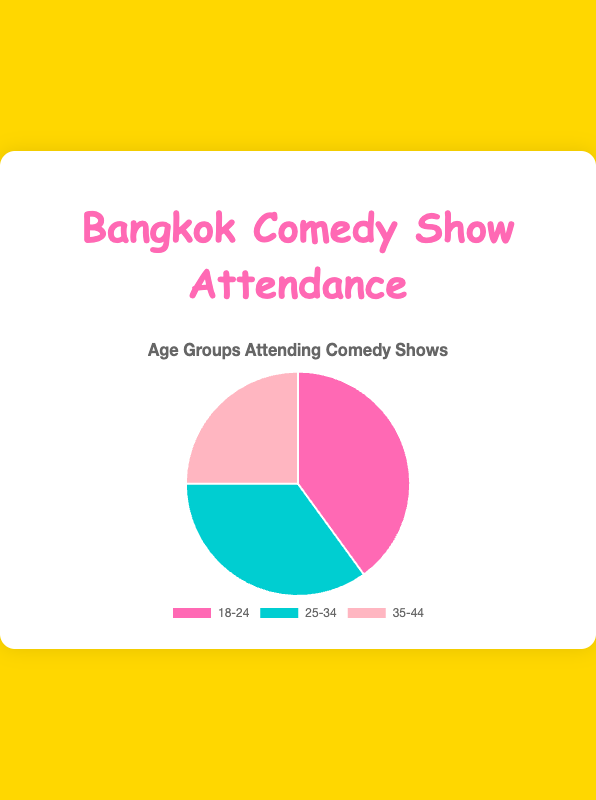Which age group attends the comedy shows the most? The pie chart shows that the "18-24" age group has the largest percentage at 40%, making it the most attended group.
Answer: 18-24 Which age group has the smallest attendance percentage? The pie chart indicates that the "35-44" age group has the smallest percentage at 25%.
Answer: 35-44 What is the total percentage of attendees aged between 25 and 44? Add the percentages of the "25-34" and "35-44" age groups: 35% + 25% = 60%.
Answer: 60% How does the attendance of the "18-24" group compare to the "25-34" group? The "18-24" group has a higher percentage (40%) compared to the "25-34" group (35%), making it the more attended age group.
Answer: 18-24 What is the difference in attendance between the "18-24" and "35-44" age groups? Subtract the percentage of the "35-44" age group (25%) from the "18-24" age group (40%): 40% - 25% = 15%.
Answer: 15% Which age group is represented by the color blue? The pie chart data indicates that the "25-34" age group is represented by the blue section.
Answer: 25-34 If we combine the "18-24" and "35-44" percentages, will they surpass the "25-34" group's percentage? Adding the percentages for "18-24" (40%) and "35-44" (25%) gives a total of 65%, which is greater than the "25-34" group's 35%.
Answer: Yes What is the average attendance percentage of all age groups? Add up all the percentages and divide by the number of groups: (40% + 35% + 25%) / 3 = 33.33%.
Answer: 33.33% How much more percentage is the "18-24" group than the "35-44" group? Subtract the percentage of the "35-44" group (25%) from the "18-24" group (40%): 40% - 25% = 15%.
Answer: 15% If the "25-34" group's percentage is increased by 10%, what will be the new percentage? Add 10% to the "25-34" group's current percentage: 35% + 10% = 45%.
Answer: 45% 